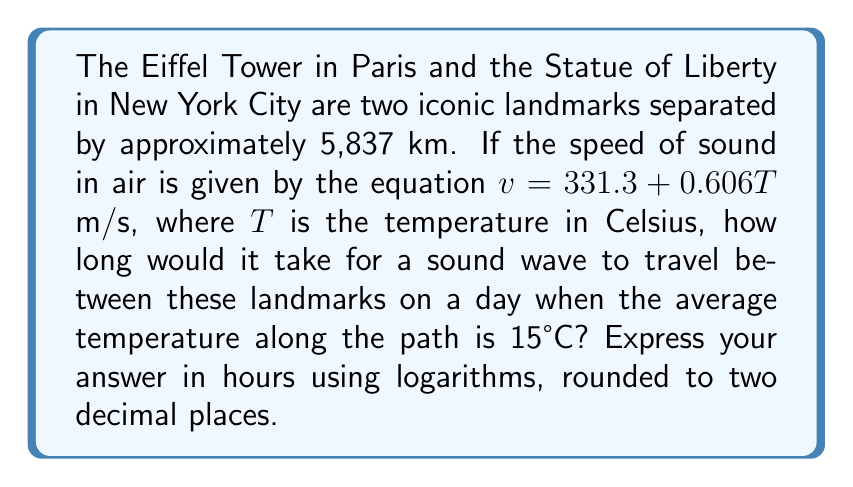Can you answer this question? Let's approach this step-by-step:

1) First, we need to calculate the speed of sound at 15°C:
   $v = 331.3 + 0.606(15) = 331.3 + 9.09 = 340.39$ m/s

2) The distance is 5,837 km = 5,837,000 m

3) Time = Distance / Speed
   $t = \frac{5,837,000}{340.39}$ seconds

4) To convert this to hours, we divide by 3600:
   $t = \frac{5,837,000}{340.39 \cdot 3600}$ hours

5) Now, let's use logarithms to simplify this calculation:
   $t = 10^{\log(\frac{5,837,000}{340.39 \cdot 3600})}$

6) Using the logarithm property $\log(a/b) = \log(a) - \log(b)$:
   $t = 10^{\log(5,837,000) - \log(340.39) - \log(3600)}$

7) Calculate:
   $\log(5,837,000) \approx 6.7662$
   $\log(340.39) \approx 2.5319$
   $\log(3600) = 3.5563$

8) Substitute:
   $t = 10^{6.7662 - 2.5319 - 3.5563} = 10^{0.6780}$

9) Calculate:
   $t \approx 4.7625$ hours

10) Rounding to two decimal places:
    $t \approx 4.76$ hours
Answer: 4.76 hours 